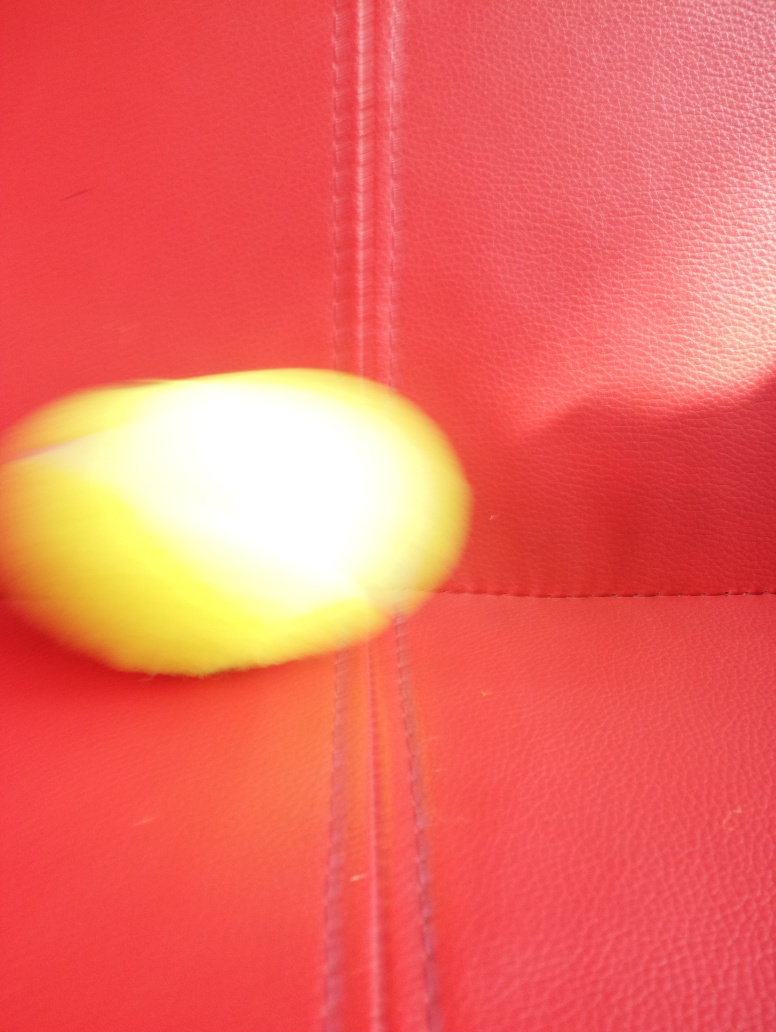What can you infer about the object's texture? While the image's blur limits a precise analysis of texture, the object seems to exhibit a smooth, perhaps glossy surface that is reflective, as suggested by the slight glint and soft color gradient on its surface. 